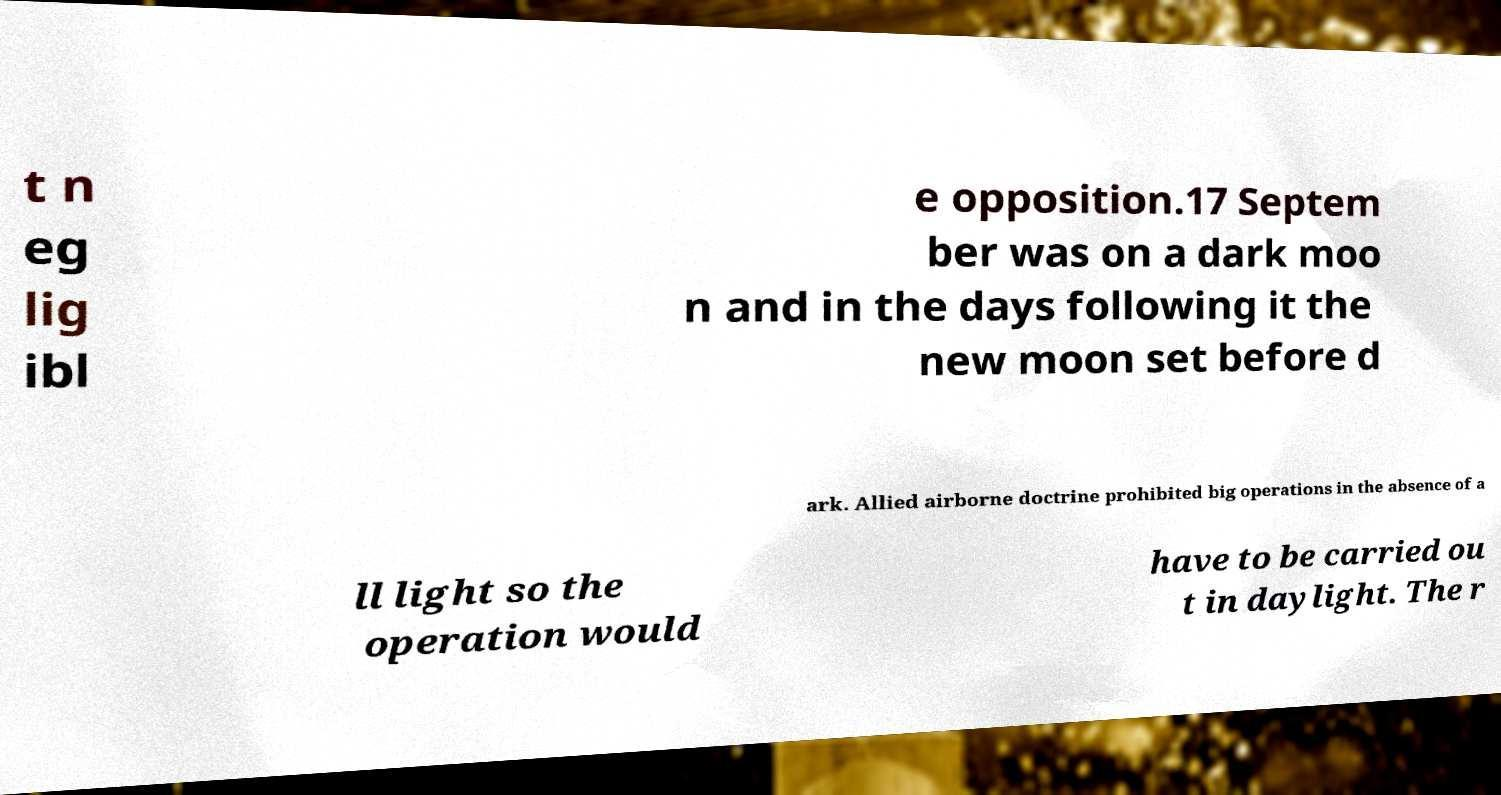I need the written content from this picture converted into text. Can you do that? t n eg lig ibl e opposition.17 Septem ber was on a dark moo n and in the days following it the new moon set before d ark. Allied airborne doctrine prohibited big operations in the absence of a ll light so the operation would have to be carried ou t in daylight. The r 